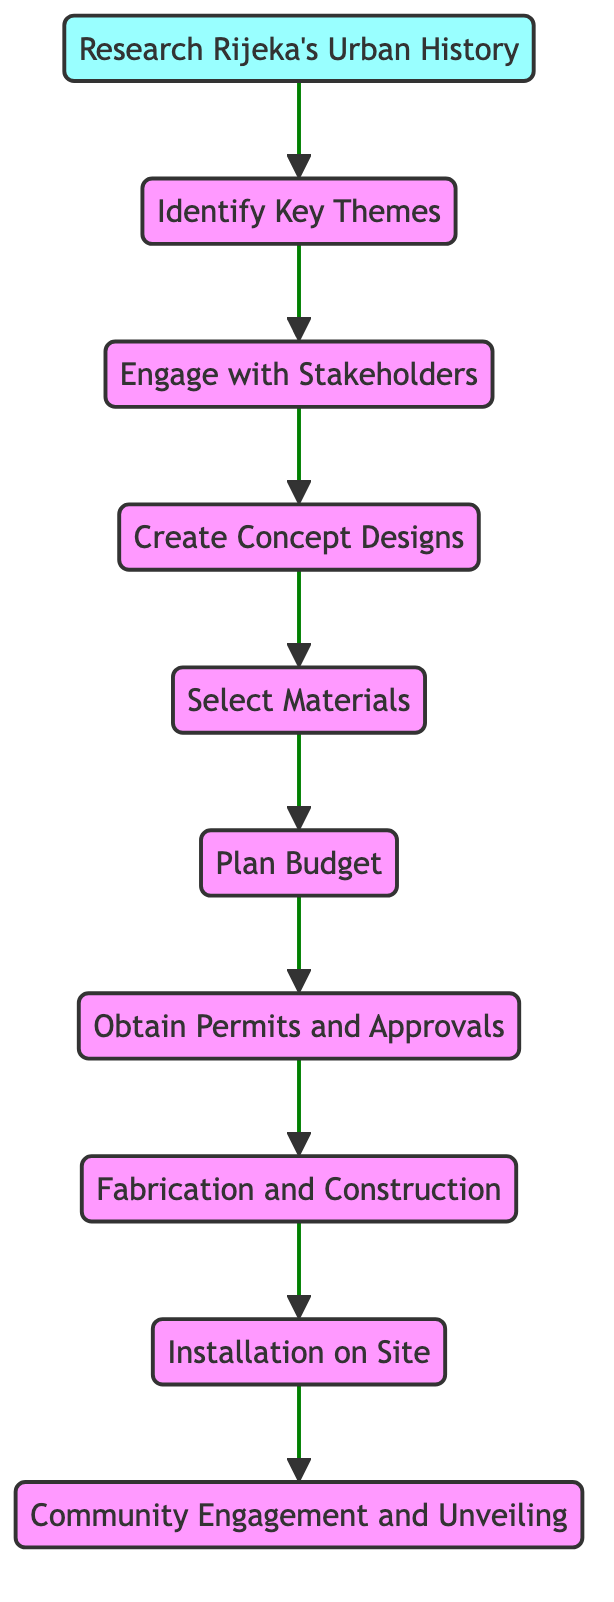What's the first step in the installation process? The first step is "Research Rijeka's Urban History," which is the starting point of the flow chart. This is indicated at the bottom of the diagram.
Answer: Research Rijeka's Urban History How many steps are there in the process? By counting the nodes in the diagram, there are a total of 10 steps, from the first step to the last step.
Answer: 10 What is the final action after "Installation on Site"? The final action in the flow is "Community Engagement and Unveiling," which follows the installation step at the top of the diagram.
Answer: Community Engagement and Unveiling Which step comes before "Budget Planning"? "Material Selection" is the step that comes directly before "Budget Planning" in the sequence of the diagram, indicated by the flow direction.
Answer: Material Selection What two steps are connected directly by an edge from "Stakeholder Engagement"? The two directly connected steps are "Stakeholder Engagement" and "Concept Design." This shows that Concept Design logically follows Stakeholder Engagement.
Answer: Concept Design What element must be completed before "Fabrication"? "Obtaining Permits and Approvals" must be completed first, as indicated by the flow leading towards Fabrication in the diagram.
Answer: Obtain Permits and Approvals Which two elements reflect community involvement in the process? "Engage with Stakeholders" and "Community Engagement and Unveiling" are the two elements that specifically highlight community involvement according to the flow chart.
Answer: Engage with Stakeholders, Community Engagement and Unveiling What is the relationship between "Concept Design" and "Material Selection"? "Concept Design" leads into "Material Selection," indicating that selecting materials comes after the concept designs have been created.
Answer: Concept Design leads to Material Selection How does one identify key themes in the project? Key themes are identified by first conducting research on Rijeka's Urban History, as shown in the flow that leads into identifying themes.
Answer: Research Rijeka's Urban History Which node is the only starting point of the flow? The only starting point in the flow chart is "Research Rijeka's Urban History," which initiates the process.
Answer: Research Rijeka's Urban History 